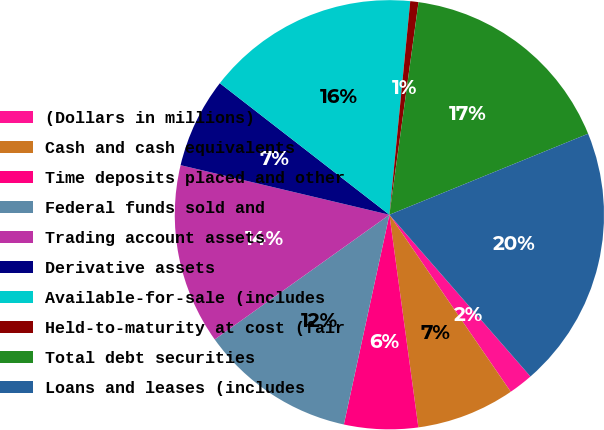Convert chart. <chart><loc_0><loc_0><loc_500><loc_500><pie_chart><fcel>(Dollars in millions)<fcel>Cash and cash equivalents<fcel>Time deposits placed and other<fcel>Federal funds sold and<fcel>Trading account assets<fcel>Derivative assets<fcel>Available-for-sale (includes<fcel>Held-to-maturity at cost (fair<fcel>Total debt securities<fcel>Loans and leases (includes<nl><fcel>1.85%<fcel>7.41%<fcel>5.56%<fcel>11.73%<fcel>13.58%<fcel>6.79%<fcel>16.05%<fcel>0.62%<fcel>16.67%<fcel>19.75%<nl></chart> 